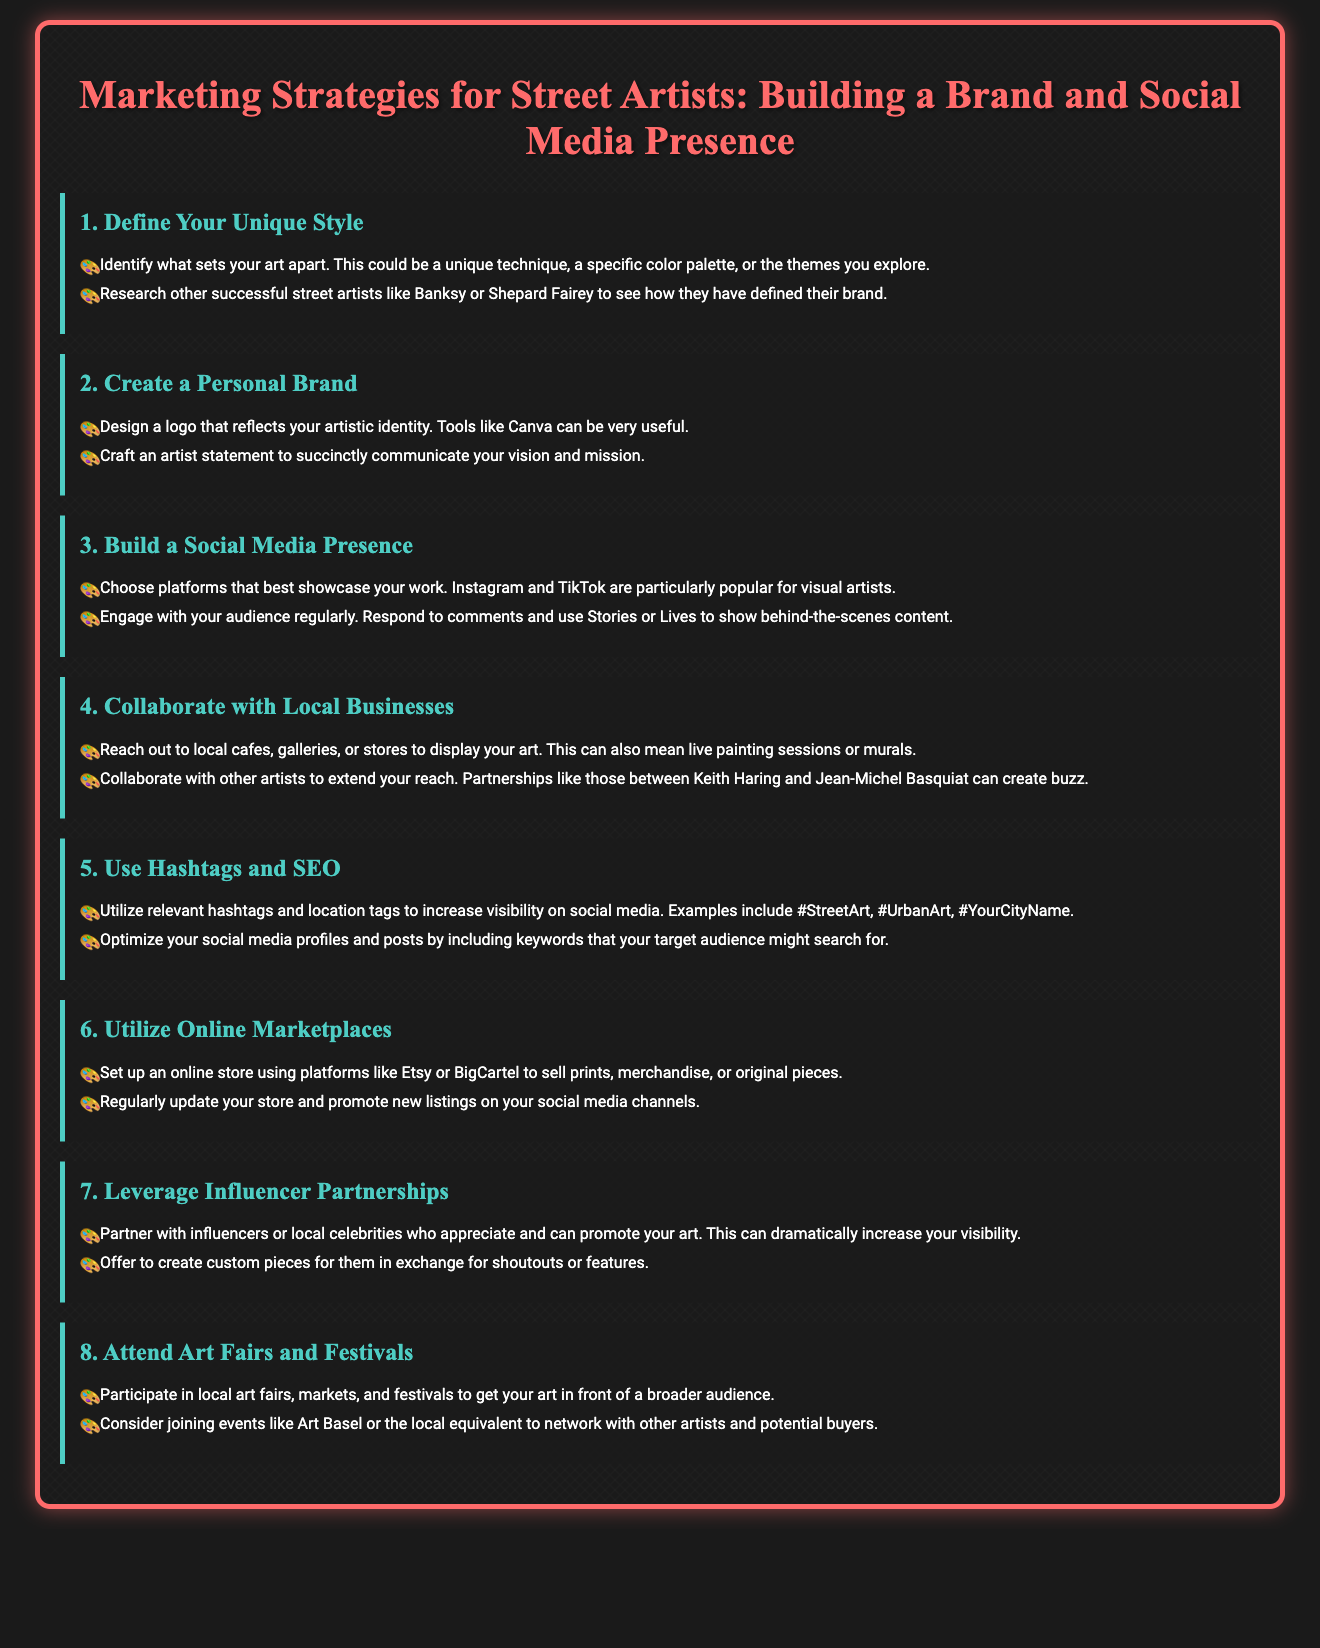What is the first step in building a brand? The document states the first step is to define your unique style.
Answer: Define Your Unique Style Which platforms are suggested for showcasing work? The document recommends Instagram and TikTok for visual artists.
Answer: Instagram and TikTok What should an artist create to communicate their vision? According to the document, an artist should craft an artist statement.
Answer: Artist statement What type of businesses can street artists collaborate with? The document mentions local cafes, galleries, or stores for collaboration.
Answer: Local cafes, galleries, or stores How should social media profiles be optimized? The document states that profiles should include keywords that the target audience might search for.
Answer: Include keywords What online marketplace is suggested for selling art? The document mentions Etsy as a platform for setting up an online store.
Answer: Etsy What is one benefit of partnering with influencers? The document states that it can dramatically increase visibility.
Answer: Increase visibility What type of events should artists attend for exposure? The document suggests local art fairs, markets, and festivals.
Answer: Local art fairs, markets, and festivals How many strategies are outlined in the presentation? The document lists eight distinct marketing strategies.
Answer: Eight 